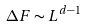<formula> <loc_0><loc_0><loc_500><loc_500>\Delta F \sim L ^ { d - 1 }</formula> 